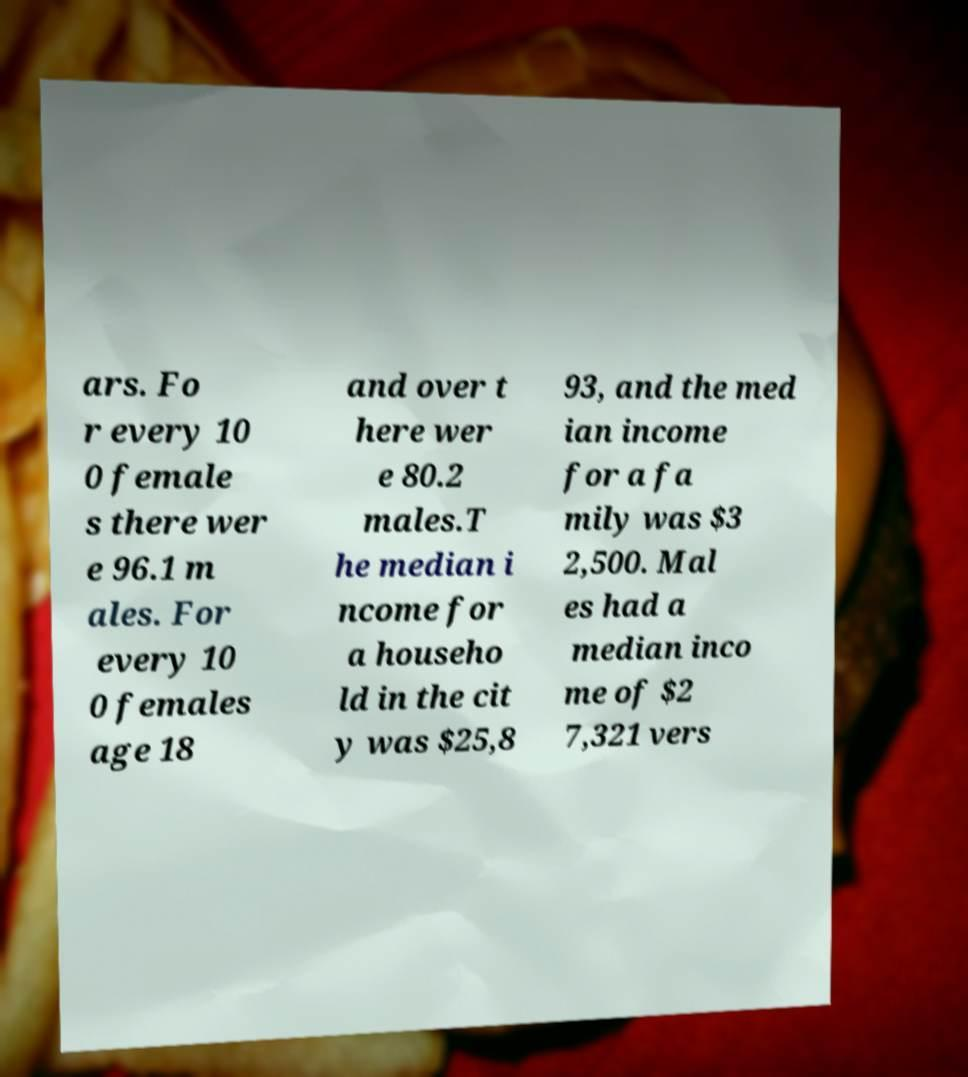Could you assist in decoding the text presented in this image and type it out clearly? ars. Fo r every 10 0 female s there wer e 96.1 m ales. For every 10 0 females age 18 and over t here wer e 80.2 males.T he median i ncome for a househo ld in the cit y was $25,8 93, and the med ian income for a fa mily was $3 2,500. Mal es had a median inco me of $2 7,321 vers 